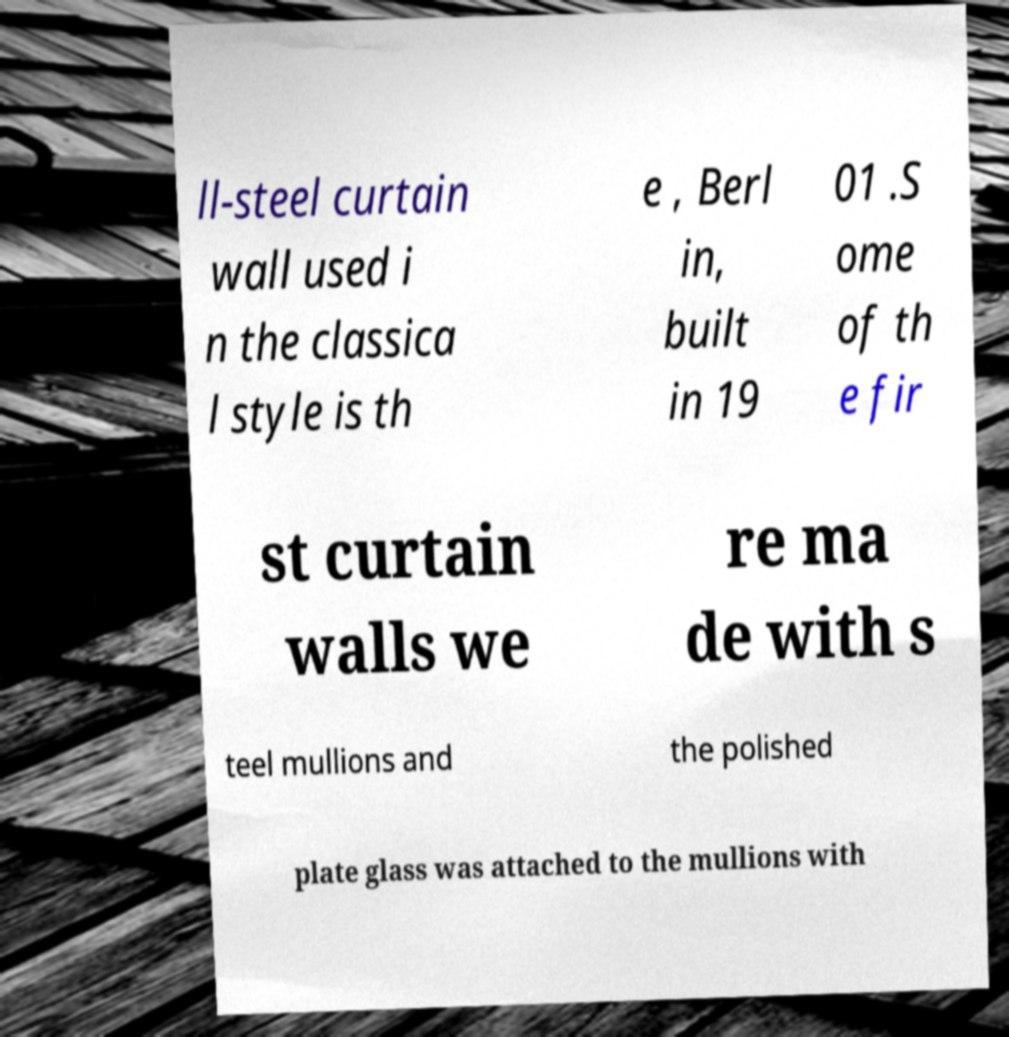For documentation purposes, I need the text within this image transcribed. Could you provide that? ll-steel curtain wall used i n the classica l style is th e , Berl in, built in 19 01 .S ome of th e fir st curtain walls we re ma de with s teel mullions and the polished plate glass was attached to the mullions with 